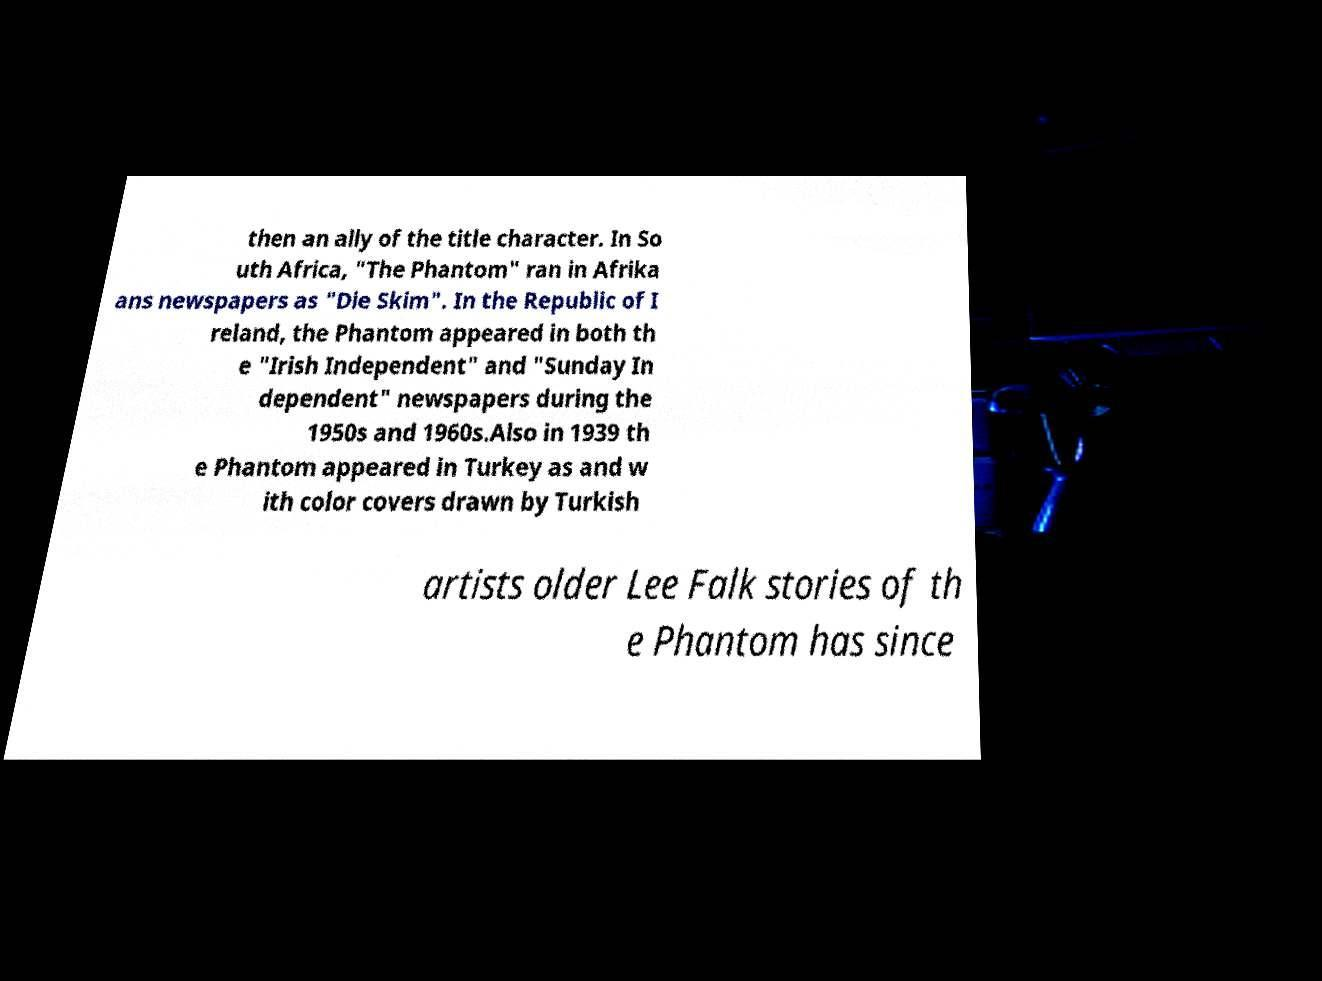There's text embedded in this image that I need extracted. Can you transcribe it verbatim? then an ally of the title character. In So uth Africa, "The Phantom" ran in Afrika ans newspapers as "Die Skim". In the Republic of I reland, the Phantom appeared in both th e "Irish Independent" and "Sunday In dependent" newspapers during the 1950s and 1960s.Also in 1939 th e Phantom appeared in Turkey as and w ith color covers drawn by Turkish artists older Lee Falk stories of th e Phantom has since 